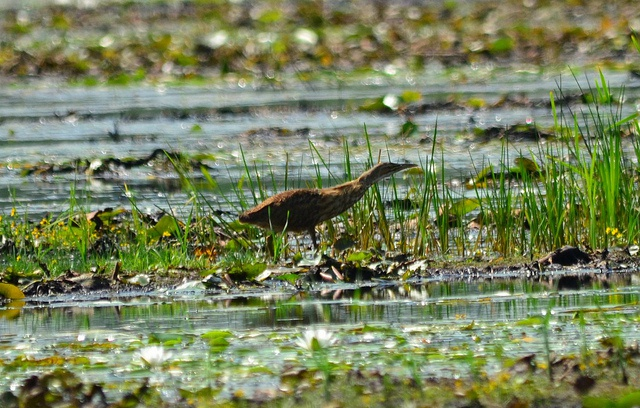Describe the objects in this image and their specific colors. I can see a bird in darkgray, black, olive, tan, and maroon tones in this image. 